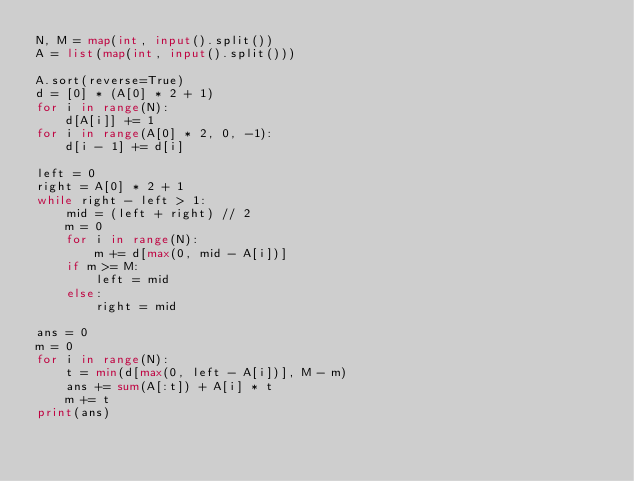<code> <loc_0><loc_0><loc_500><loc_500><_Python_>N, M = map(int, input().split())
A = list(map(int, input().split()))

A.sort(reverse=True)
d = [0] * (A[0] * 2 + 1)
for i in range(N):
    d[A[i]] += 1
for i in range(A[0] * 2, 0, -1):
    d[i - 1] += d[i]

left = 0
right = A[0] * 2 + 1
while right - left > 1:
    mid = (left + right) // 2
    m = 0
    for i in range(N):
        m += d[max(0, mid - A[i])]
    if m >= M:
        left = mid
    else:
        right = mid

ans = 0
m = 0
for i in range(N):
    t = min(d[max(0, left - A[i])], M - m)
    ans += sum(A[:t]) + A[i] * t
    m += t
print(ans)
</code> 